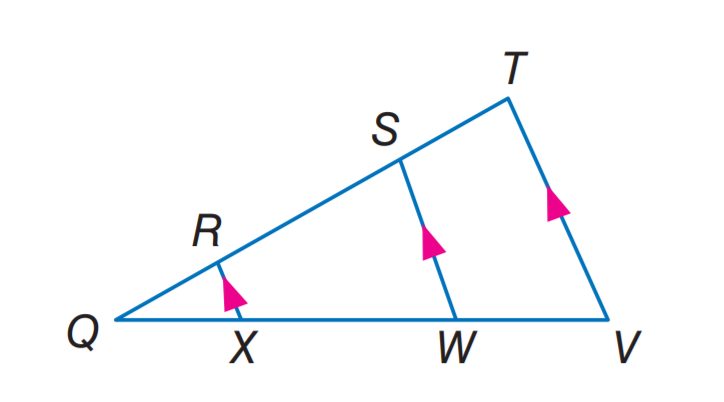Answer the mathemtical geometry problem and directly provide the correct option letter.
Question: If Q R = 2, X W = 12, Q W = 15, and S T = 5, find R S.
Choices: A: 5 B: 7.5 C: 8 D: 12 C 